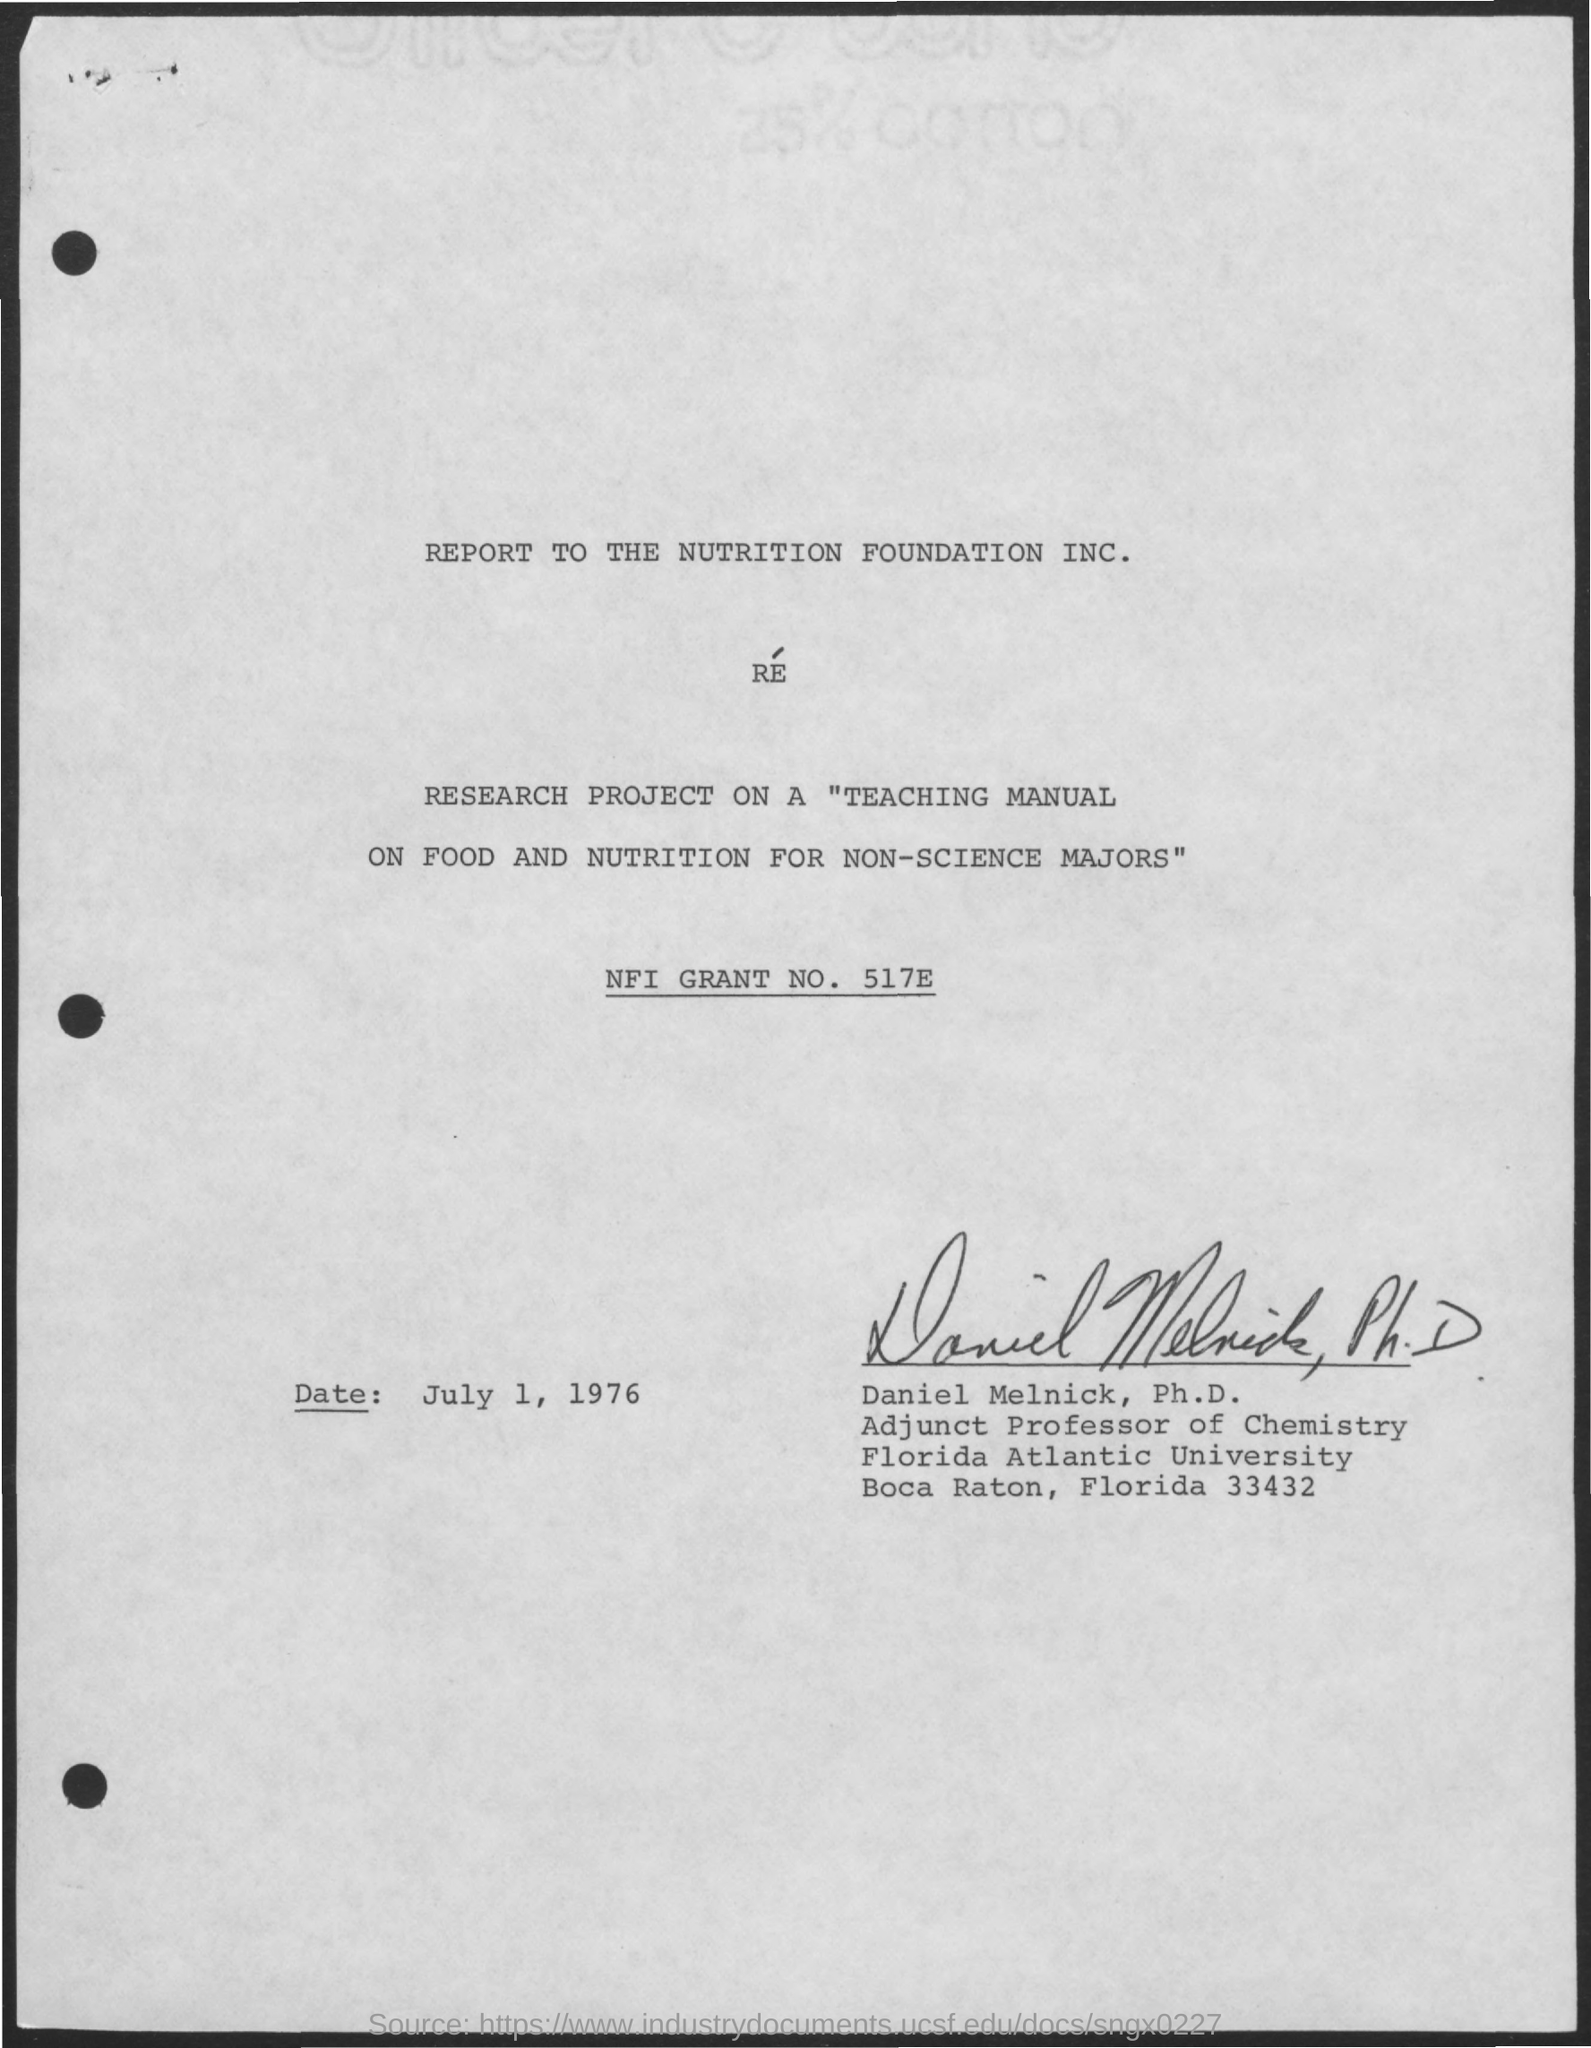Identify some key points in this picture. The project mentioned in the given page is called 'Teaching Manual On Food And Nutrition for Non-science Majors.' Daniel Melnick is a student at Florida Atlantic University. The date mentioned in the given page is July 1, 1976. Daniel Melnick is an adjunct professor of chemistry, as mentioned on the given page. This report is submitted to The Nutrition Foundation Inc. 